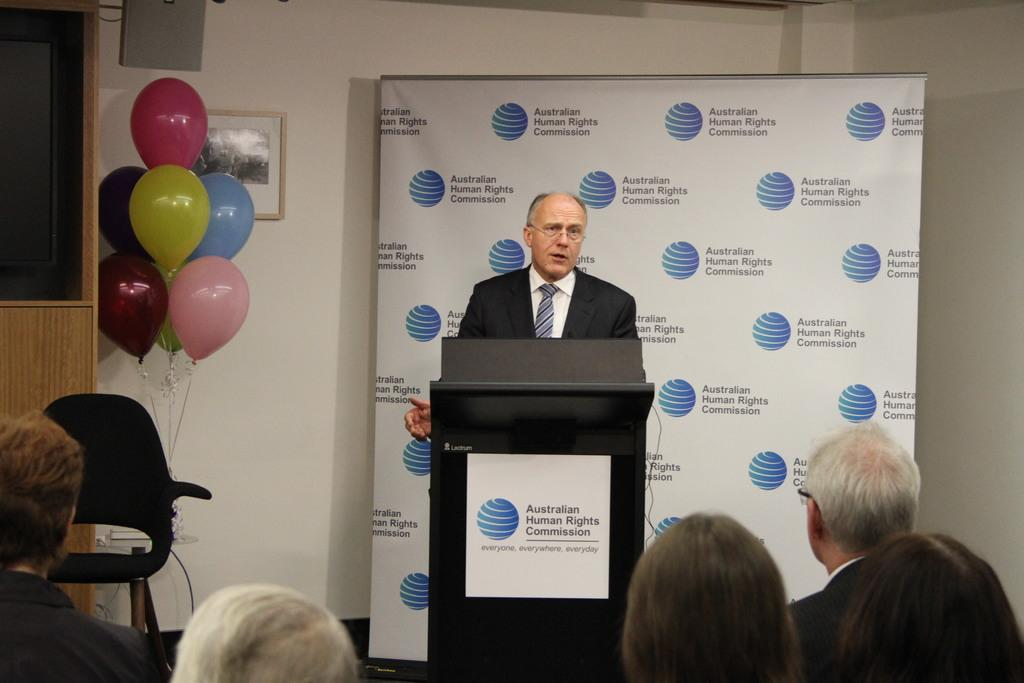<image>
Offer a succinct explanation of the picture presented. The male speaking is at a conference for Human Rights. 